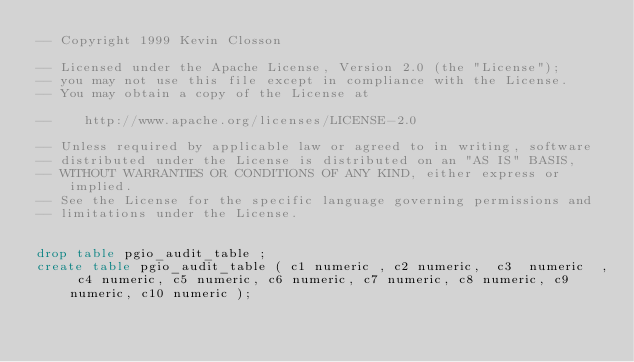Convert code to text. <code><loc_0><loc_0><loc_500><loc_500><_SQL_>-- Copyright 1999 Kevin Closson

-- Licensed under the Apache License, Version 2.0 (the "License");
-- you may not use this file except in compliance with the License.
-- You may obtain a copy of the License at

--    http://www.apache.org/licenses/LICENSE-2.0

-- Unless required by applicable law or agreed to in writing, software
-- distributed under the License is distributed on an "AS IS" BASIS,
-- WITHOUT WARRANTIES OR CONDITIONS OF ANY KIND, either express or implied.
-- See the License for the specific language governing permissions and
-- limitations under the License.


drop table pgio_audit_table ;
create table pgio_audit_table ( c1 numeric , c2 numeric,  c3  numeric  , c4 numeric, c5 numeric, c6 numeric, c7 numeric, c8 numeric, c9 numeric, c10 numeric );


</code> 